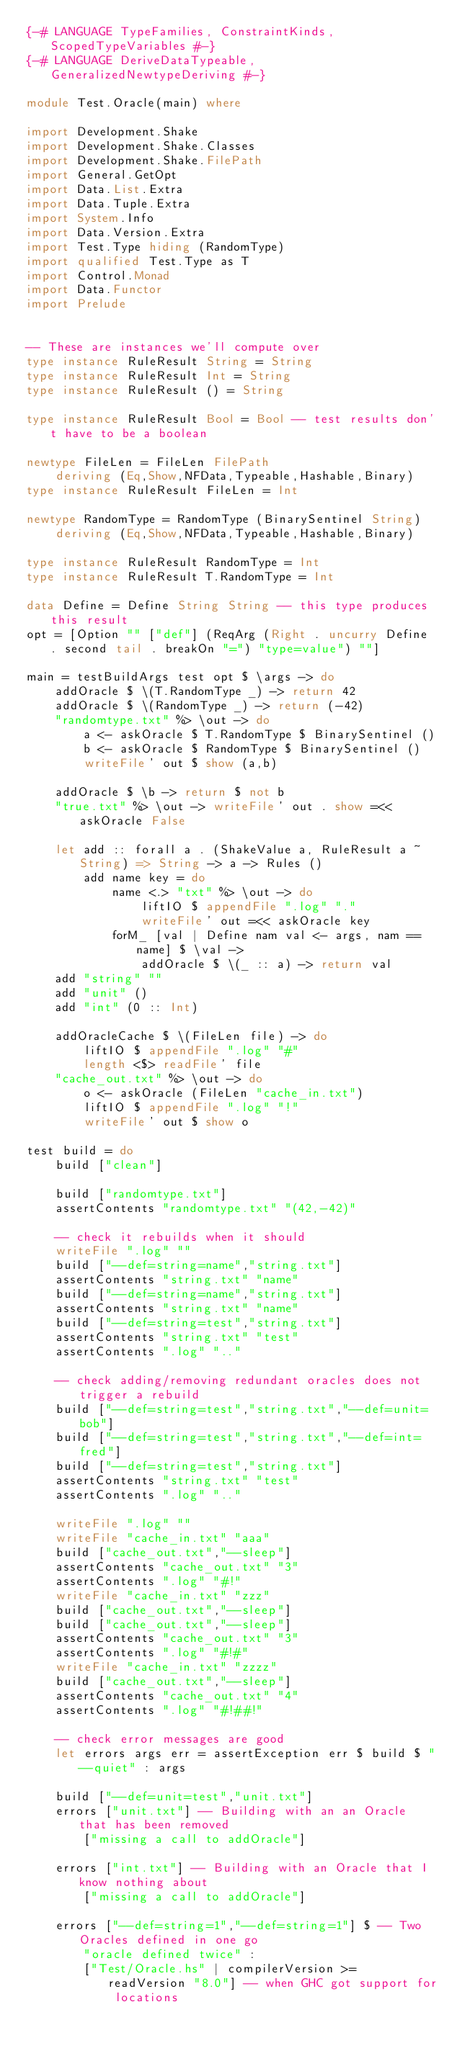Convert code to text. <code><loc_0><loc_0><loc_500><loc_500><_Haskell_>{-# LANGUAGE TypeFamilies, ConstraintKinds, ScopedTypeVariables #-}
{-# LANGUAGE DeriveDataTypeable, GeneralizedNewtypeDeriving #-}

module Test.Oracle(main) where

import Development.Shake
import Development.Shake.Classes
import Development.Shake.FilePath
import General.GetOpt
import Data.List.Extra
import Data.Tuple.Extra
import System.Info
import Data.Version.Extra
import Test.Type hiding (RandomType)
import qualified Test.Type as T
import Control.Monad
import Data.Functor
import Prelude


-- These are instances we'll compute over
type instance RuleResult String = String
type instance RuleResult Int = String
type instance RuleResult () = String

type instance RuleResult Bool = Bool -- test results don't have to be a boolean

newtype FileLen = FileLen FilePath
    deriving (Eq,Show,NFData,Typeable,Hashable,Binary)
type instance RuleResult FileLen = Int

newtype RandomType = RandomType (BinarySentinel String)
    deriving (Eq,Show,NFData,Typeable,Hashable,Binary)

type instance RuleResult RandomType = Int
type instance RuleResult T.RandomType = Int

data Define = Define String String -- this type produces this result
opt = [Option "" ["def"] (ReqArg (Right . uncurry Define . second tail . breakOn "=") "type=value") ""]

main = testBuildArgs test opt $ \args -> do
    addOracle $ \(T.RandomType _) -> return 42
    addOracle $ \(RandomType _) -> return (-42)
    "randomtype.txt" %> \out -> do
        a <- askOracle $ T.RandomType $ BinarySentinel ()
        b <- askOracle $ RandomType $ BinarySentinel ()
        writeFile' out $ show (a,b)

    addOracle $ \b -> return $ not b
    "true.txt" %> \out -> writeFile' out . show =<< askOracle False

    let add :: forall a . (ShakeValue a, RuleResult a ~ String) => String -> a -> Rules ()
        add name key = do
            name <.> "txt" %> \out -> do
                liftIO $ appendFile ".log" "."
                writeFile' out =<< askOracle key
            forM_ [val | Define nam val <- args, nam == name] $ \val ->
                addOracle $ \(_ :: a) -> return val
    add "string" ""
    add "unit" ()
    add "int" (0 :: Int)

    addOracleCache $ \(FileLen file) -> do
        liftIO $ appendFile ".log" "#"
        length <$> readFile' file
    "cache_out.txt" %> \out -> do
        o <- askOracle (FileLen "cache_in.txt")
        liftIO $ appendFile ".log" "!"
        writeFile' out $ show o

test build = do
    build ["clean"]

    build ["randomtype.txt"]
    assertContents "randomtype.txt" "(42,-42)"

    -- check it rebuilds when it should
    writeFile ".log" ""
    build ["--def=string=name","string.txt"]
    assertContents "string.txt" "name"
    build ["--def=string=name","string.txt"]
    assertContents "string.txt" "name"
    build ["--def=string=test","string.txt"]
    assertContents "string.txt" "test"
    assertContents ".log" ".."

    -- check adding/removing redundant oracles does not trigger a rebuild
    build ["--def=string=test","string.txt","--def=unit=bob"]
    build ["--def=string=test","string.txt","--def=int=fred"]
    build ["--def=string=test","string.txt"]
    assertContents "string.txt" "test"
    assertContents ".log" ".."

    writeFile ".log" ""
    writeFile "cache_in.txt" "aaa"
    build ["cache_out.txt","--sleep"]
    assertContents "cache_out.txt" "3"
    assertContents ".log" "#!"
    writeFile "cache_in.txt" "zzz"
    build ["cache_out.txt","--sleep"]
    build ["cache_out.txt","--sleep"]
    assertContents "cache_out.txt" "3"
    assertContents ".log" "#!#"
    writeFile "cache_in.txt" "zzzz"
    build ["cache_out.txt","--sleep"]
    assertContents "cache_out.txt" "4"
    assertContents ".log" "#!##!"

    -- check error messages are good
    let errors args err = assertException err $ build $ "--quiet" : args

    build ["--def=unit=test","unit.txt"]
    errors ["unit.txt"] -- Building with an an Oracle that has been removed
        ["missing a call to addOracle"]

    errors ["int.txt"] -- Building with an Oracle that I know nothing about
        ["missing a call to addOracle"]

    errors ["--def=string=1","--def=string=1"] $ -- Two Oracles defined in one go
        "oracle defined twice" :
        ["Test/Oracle.hs" | compilerVersion >= readVersion "8.0"] -- when GHC got support for locations
</code> 